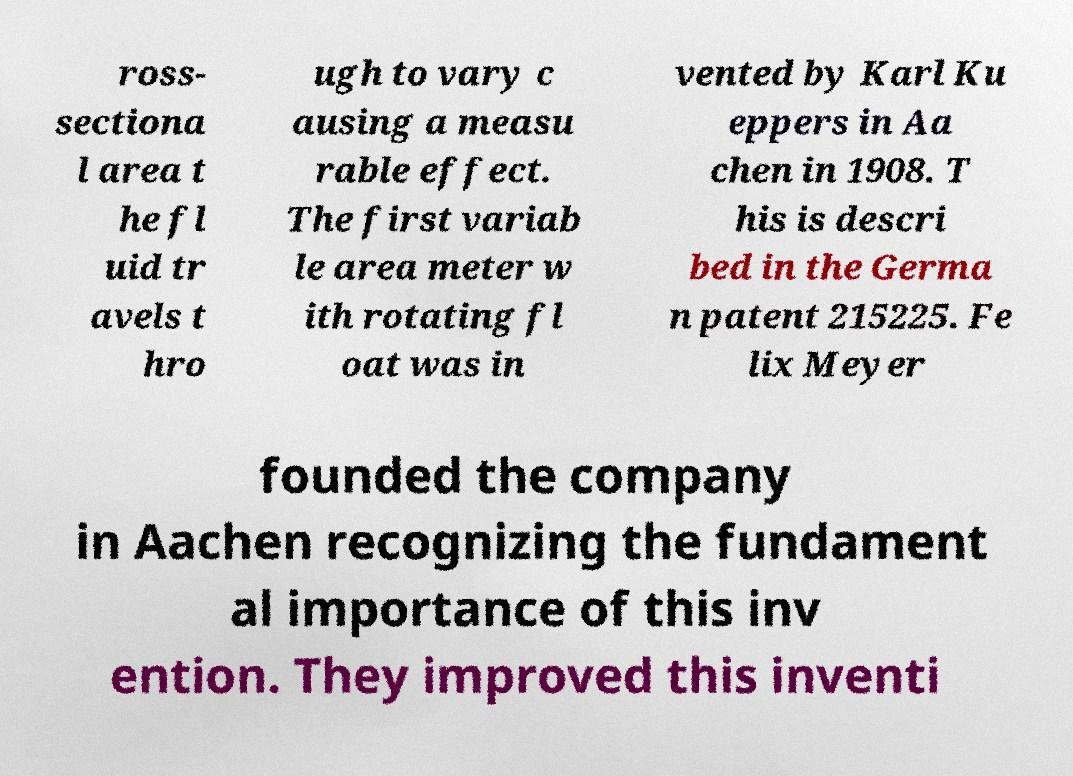Could you extract and type out the text from this image? ross- sectiona l area t he fl uid tr avels t hro ugh to vary c ausing a measu rable effect. The first variab le area meter w ith rotating fl oat was in vented by Karl Ku eppers in Aa chen in 1908. T his is descri bed in the Germa n patent 215225. Fe lix Meyer founded the company in Aachen recognizing the fundament al importance of this inv ention. They improved this inventi 